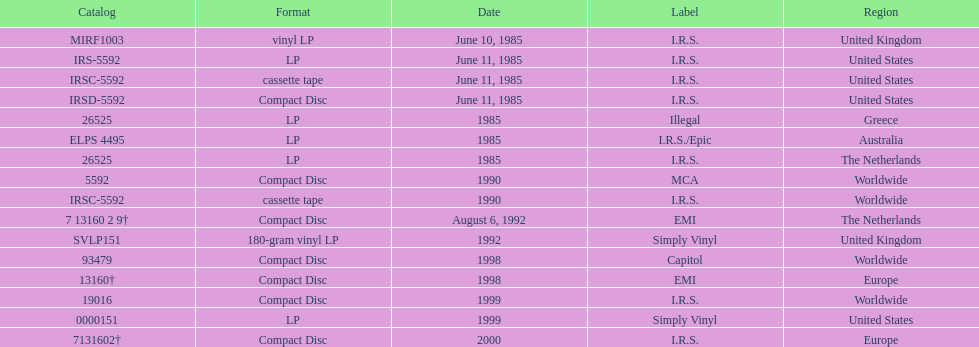Which region has more than one format? United States. 